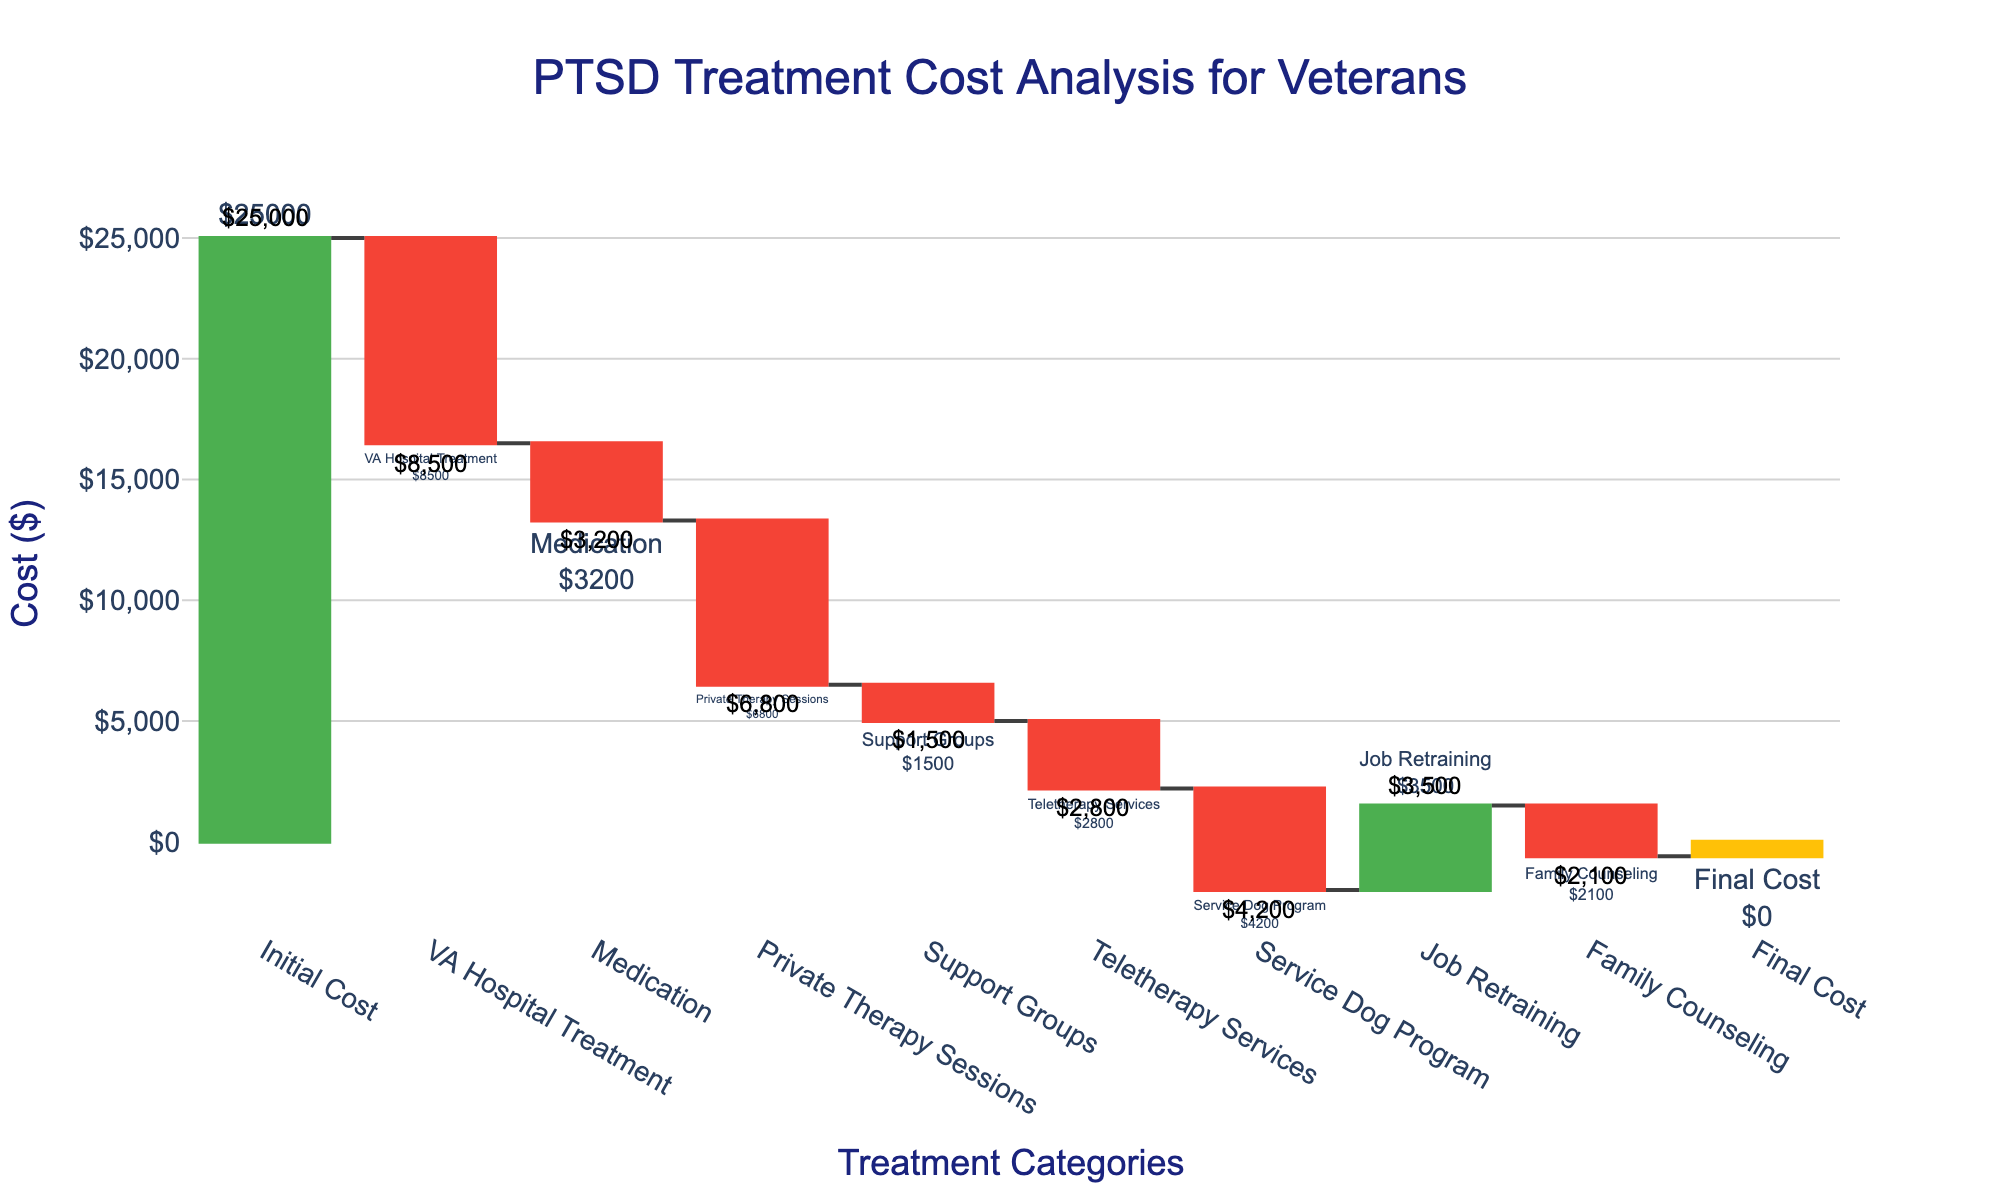What is the total initial cost shown in the chart? The chart starts with an initial cost of $25,000 as indicated at the top of the waterfall.
Answer: $25,000 How much cost is reduced by VA Hospital Treatment? From the chart, VA Hospital Treatment has a negative bar that reduces the cost by $8,500.
Answer: $8,500 Which treatment category contributes the least cost reduction? Comparing all negative values, the Support Groups category has the smallest reduction of $1,500.
Answer: $1,500 What's the difference in cost reduction between Medication and Private Therapy Sessions? Medication reduces cost by $3,200 and Private Therapy Sessions reduce cost by $6,800. The difference is $6,800 - $3,200 = $3,600.
Answer: $3,600 What is the net cost change after applying all treatment categories except Job Retraining and Family Counseling? Sum the values except Job Retraining (+$3,500) and Family Counseling (–$2,100): $25,000 - $8,500 - $3,200 - $6,800 - $1,500 - $2,800 - $4,200 = -$2,000.
Answer: -$2,000 How does the cost reduction of Private Therapy Sessions compare to that of the Service Dog Program? Private Therapy Sessions reduce costs by $6,800, whereas the Service Dog Program reduces costs by $4,200. Private Therapy Sessions provide a $2,600 greater cost reduction.
Answer: $2,600 Which category shows a positive contribution to cost added? The only positive category shown in the chart is Job Retraining, which adds $3,500 to the cost.
Answer: Job Retraining What is the cumulative cost after Private Therapy Sessions? Start with $25,000, and subtract VA Hospital Treatment ($8,500) and Medication ($3,200), and Private Therapy Sessions ($6,800): $25,000 - $8,500 - $3,200 - $6,800 = $6,500.
Answer: $6,500 What does the bar for Family Counseling indicate? The Family Counseling bar indicates a cost reduction of $2,100.
Answer: $2,100 Is the final cost equal to the initial cost in the chart? The chart shows a final cost of $0, which indicates that all the costs and contributions offset each other entirely.
Answer: Yes 